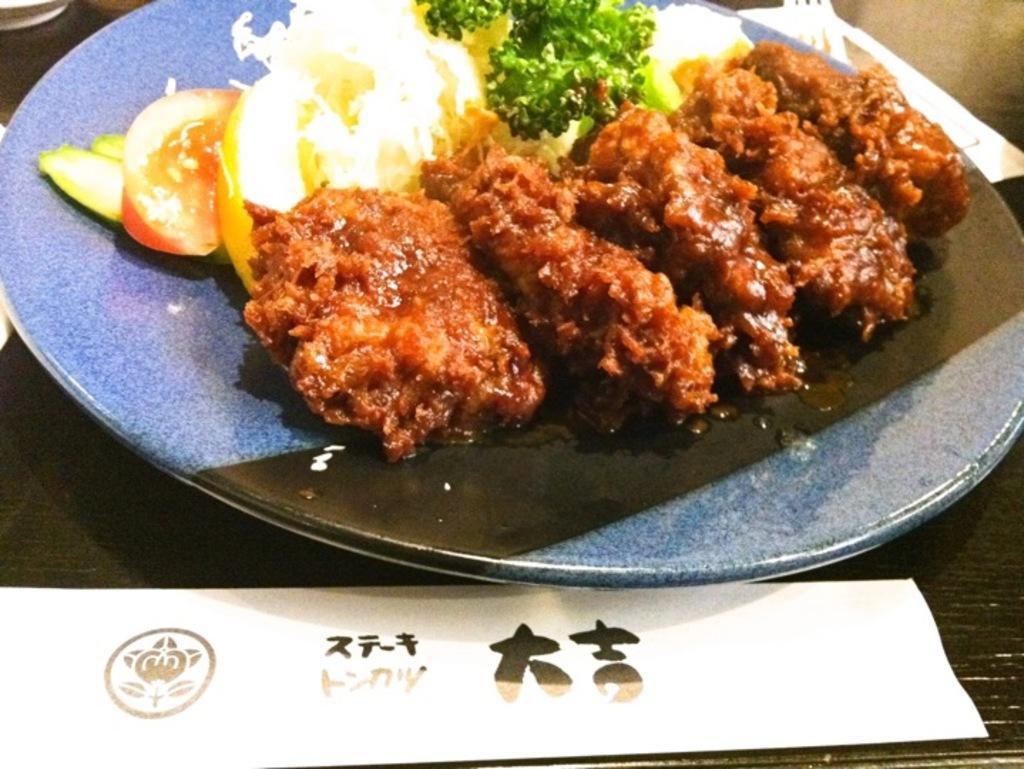Please provide a concise description of this image. Here we can see food items in a plate on a platform and at the bottom we can see a text written on a paper on a platform and at the top there are objects and fork on the platform. 